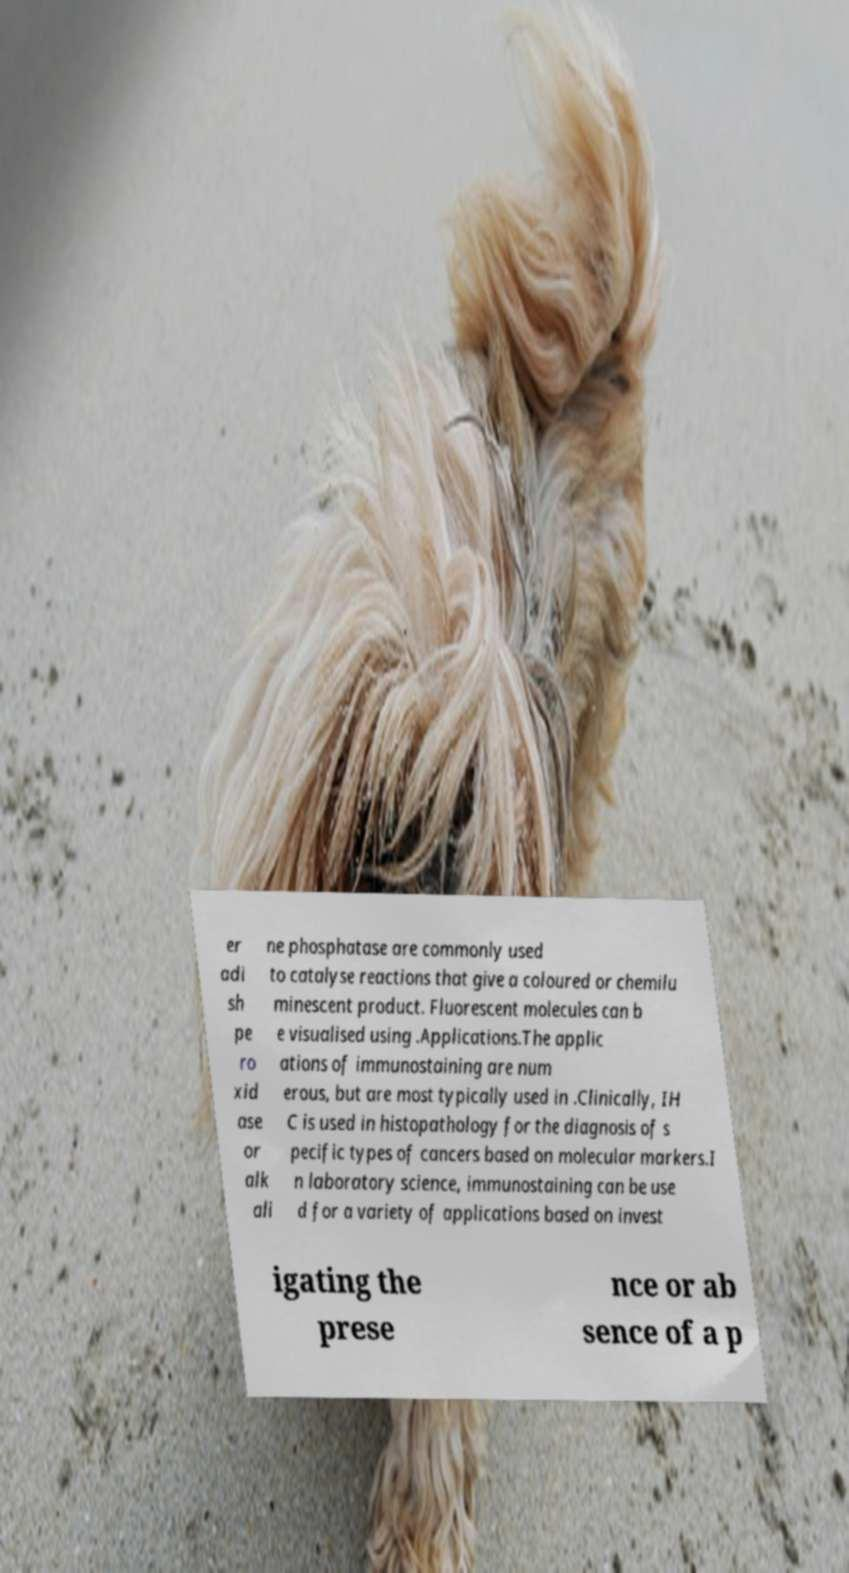For documentation purposes, I need the text within this image transcribed. Could you provide that? er adi sh pe ro xid ase or alk ali ne phosphatase are commonly used to catalyse reactions that give a coloured or chemilu minescent product. Fluorescent molecules can b e visualised using .Applications.The applic ations of immunostaining are num erous, but are most typically used in .Clinically, IH C is used in histopathology for the diagnosis of s pecific types of cancers based on molecular markers.I n laboratory science, immunostaining can be use d for a variety of applications based on invest igating the prese nce or ab sence of a p 